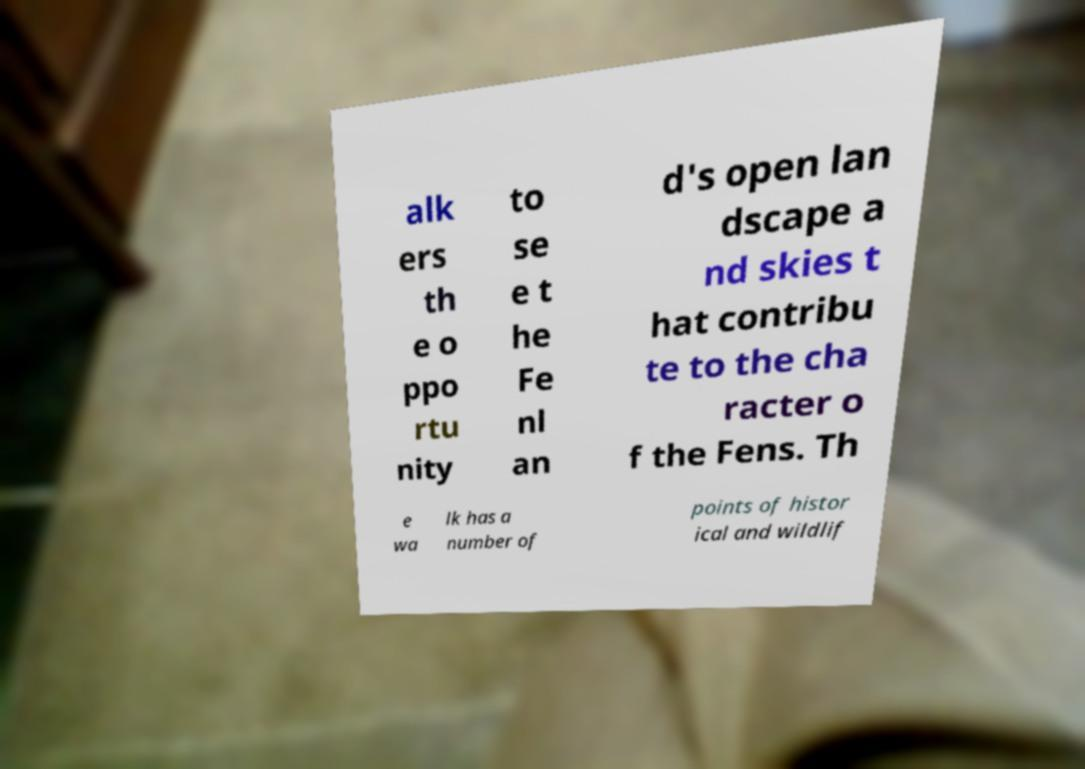Can you read and provide the text displayed in the image?This photo seems to have some interesting text. Can you extract and type it out for me? alk ers th e o ppo rtu nity to se e t he Fe nl an d's open lan dscape a nd skies t hat contribu te to the cha racter o f the Fens. Th e wa lk has a number of points of histor ical and wildlif 